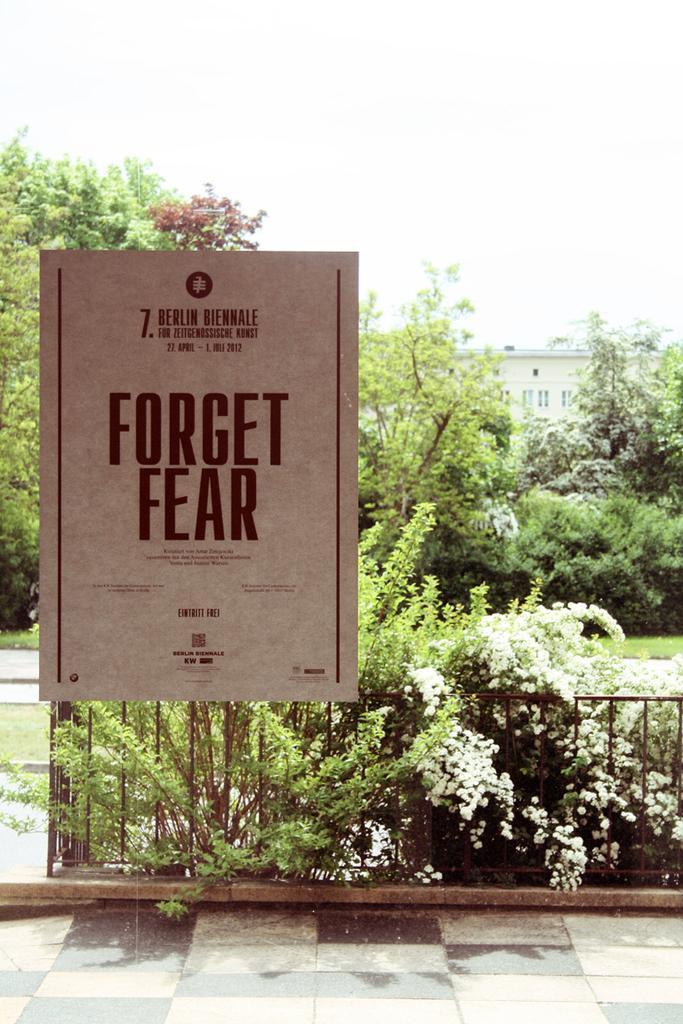How would you summarize this image in a sentence or two? In this image we can see a board with some text on it, some plants, grass, a group of trees, a fence, a building with windows and the sky. 